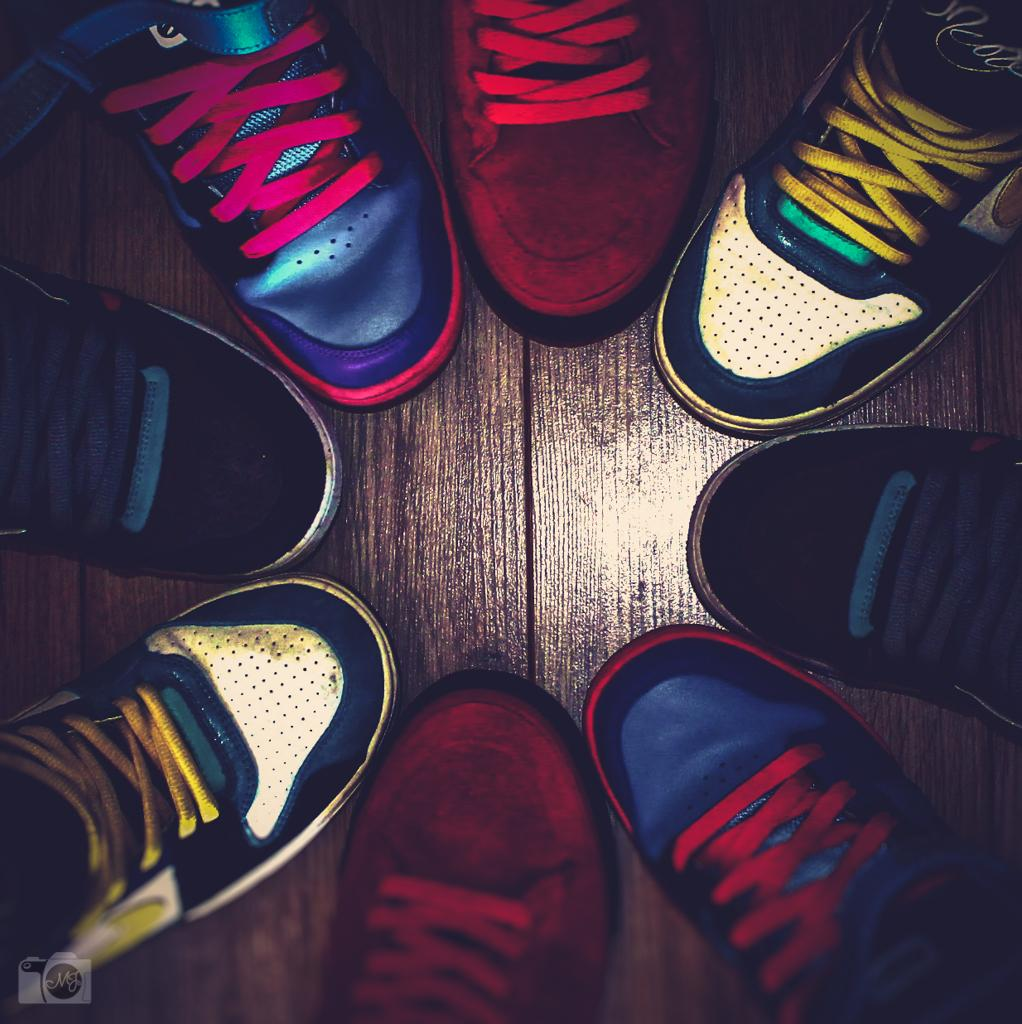What type of objects are in the image? There are shoes in the image. Can you describe the appearance of the shoes? The shoes are colorful. What is the shoes resting on in the image? The shoes are on a brown surface. What story is being told by the cats in the image? There are no cats present in the image, so no story can be told by them. 